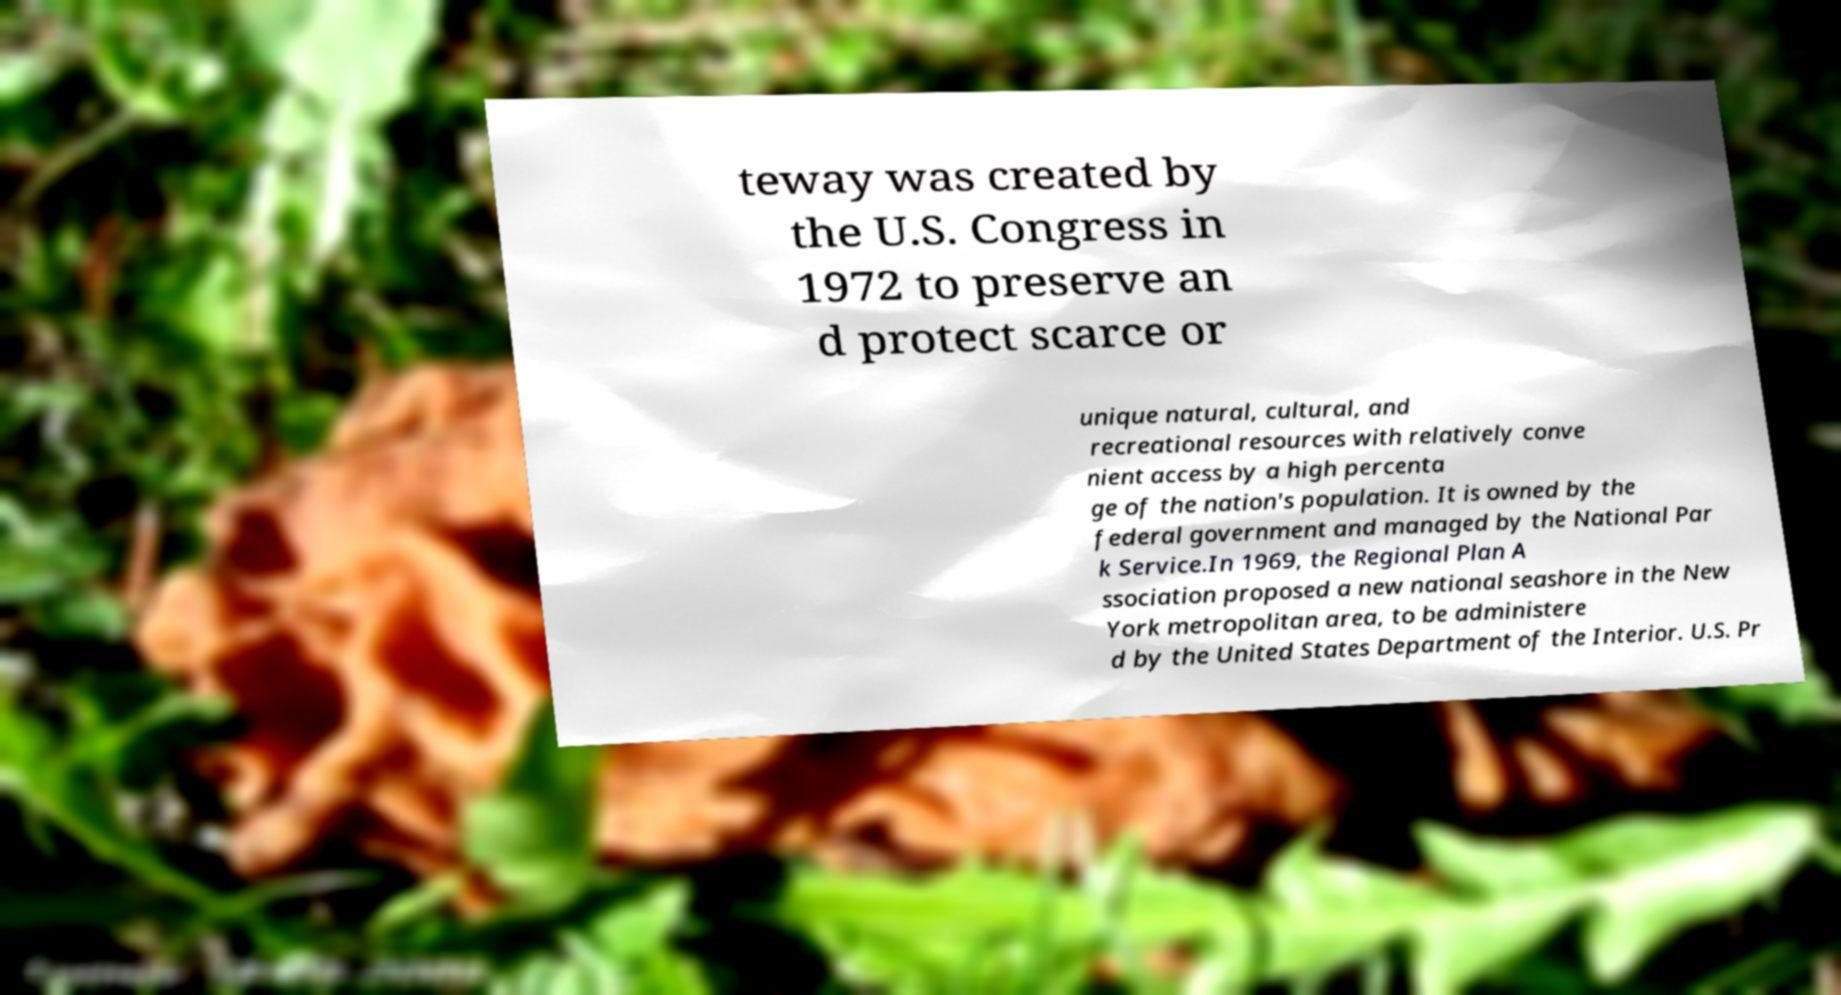There's text embedded in this image that I need extracted. Can you transcribe it verbatim? teway was created by the U.S. Congress in 1972 to preserve an d protect scarce or unique natural, cultural, and recreational resources with relatively conve nient access by a high percenta ge of the nation's population. It is owned by the federal government and managed by the National Par k Service.In 1969, the Regional Plan A ssociation proposed a new national seashore in the New York metropolitan area, to be administere d by the United States Department of the Interior. U.S. Pr 